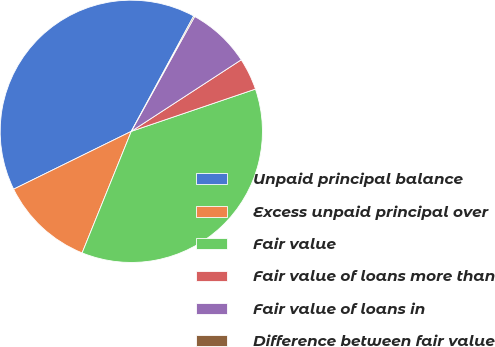Convert chart. <chart><loc_0><loc_0><loc_500><loc_500><pie_chart><fcel>Unpaid principal balance<fcel>Excess unpaid principal over<fcel>Fair value<fcel>Fair value of loans more than<fcel>Fair value of loans in<fcel>Difference between fair value<nl><fcel>40.16%<fcel>11.61%<fcel>36.34%<fcel>3.96%<fcel>7.79%<fcel>0.14%<nl></chart> 